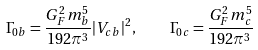Convert formula to latex. <formula><loc_0><loc_0><loc_500><loc_500>\Gamma _ { 0 b } = \frac { G _ { F } ^ { 2 } m _ { b } ^ { 5 } } { 1 9 2 { \pi } ^ { 3 } } | V _ { c b } | ^ { 2 } , \quad \Gamma _ { 0 c } = \frac { G _ { F } ^ { 2 } m _ { c } ^ { 5 } } { 1 9 2 { \pi } ^ { 3 } }</formula> 